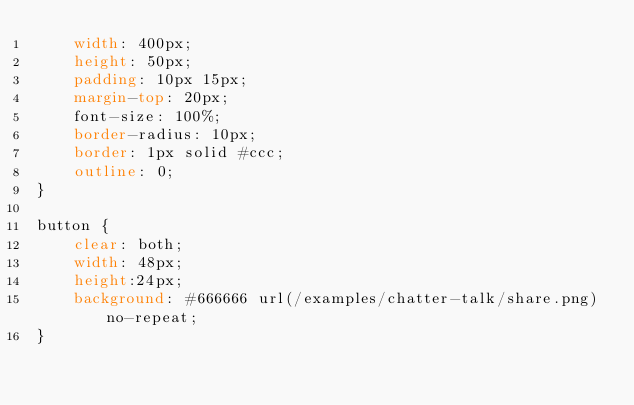<code> <loc_0><loc_0><loc_500><loc_500><_CSS_>    width: 400px;
    height: 50px;
    padding: 10px 15px;
    margin-top: 20px;
    font-size: 100%;
    border-radius: 10px;
    border: 1px solid #ccc;
    outline: 0;
}

button {
    clear: both;
    width: 48px;
    height:24px;
    background: #666666 url(/examples/chatter-talk/share.png) no-repeat;
}</code> 